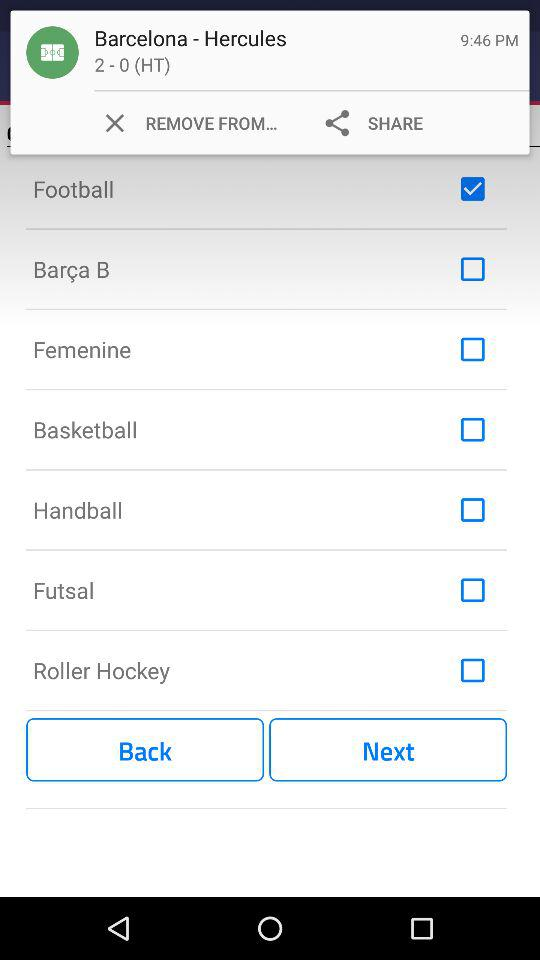Which option is selected? The selected option is "Football". 